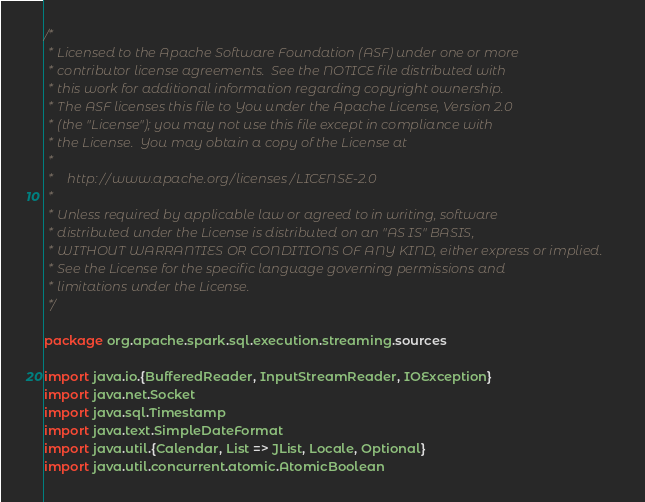<code> <loc_0><loc_0><loc_500><loc_500><_Scala_>/*
 * Licensed to the Apache Software Foundation (ASF) under one or more
 * contributor license agreements.  See the NOTICE file distributed with
 * this work for additional information regarding copyright ownership.
 * The ASF licenses this file to You under the Apache License, Version 2.0
 * (the "License"); you may not use this file except in compliance with
 * the License.  You may obtain a copy of the License at
 *
 *    http://www.apache.org/licenses/LICENSE-2.0
 *
 * Unless required by applicable law or agreed to in writing, software
 * distributed under the License is distributed on an "AS IS" BASIS,
 * WITHOUT WARRANTIES OR CONDITIONS OF ANY KIND, either express or implied.
 * See the License for the specific language governing permissions and
 * limitations under the License.
 */

package org.apache.spark.sql.execution.streaming.sources

import java.io.{BufferedReader, InputStreamReader, IOException}
import java.net.Socket
import java.sql.Timestamp
import java.text.SimpleDateFormat
import java.util.{Calendar, List => JList, Locale, Optional}
import java.util.concurrent.atomic.AtomicBoolean</code> 